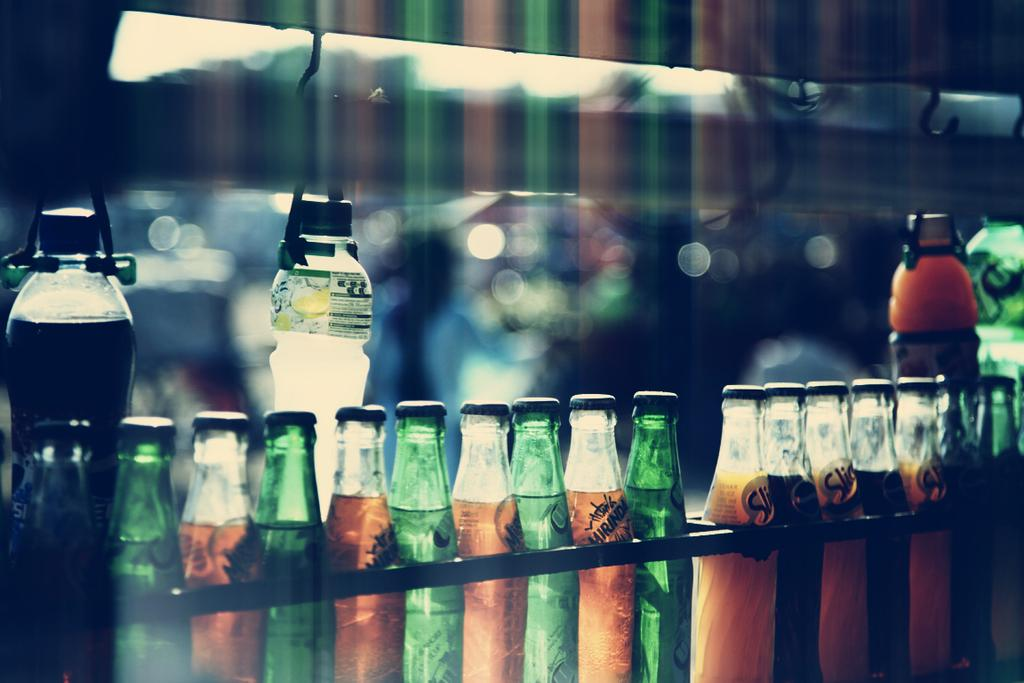What type of drink bottles are featured in the image? The image contains preservative cool drink bottles. How are the bottles emphasized in the picture? The bottles are highlighted in the picture. What is used to hold the bottles in the image? There are hooks on which the bottles are changed. What type of pickle is being prepared by the beginner laborer in the image? There is no pickle or laborer present in the image; it features preservative cool drink bottles and hooks. 